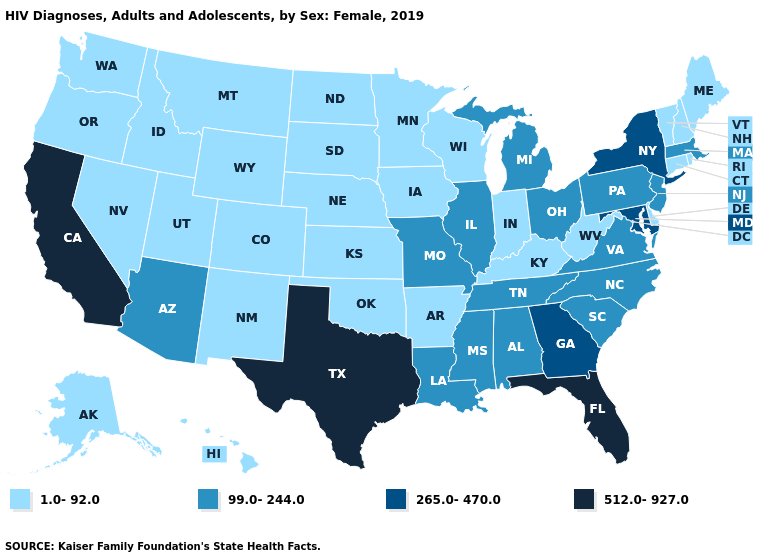Does New Mexico have a higher value than Kansas?
Quick response, please. No. Name the states that have a value in the range 1.0-92.0?
Write a very short answer. Alaska, Arkansas, Colorado, Connecticut, Delaware, Hawaii, Idaho, Indiana, Iowa, Kansas, Kentucky, Maine, Minnesota, Montana, Nebraska, Nevada, New Hampshire, New Mexico, North Dakota, Oklahoma, Oregon, Rhode Island, South Dakota, Utah, Vermont, Washington, West Virginia, Wisconsin, Wyoming. What is the value of Arkansas?
Write a very short answer. 1.0-92.0. What is the value of New Jersey?
Be succinct. 99.0-244.0. Among the states that border Indiana , which have the lowest value?
Concise answer only. Kentucky. Does Massachusetts have the lowest value in the USA?
Be succinct. No. Among the states that border Pennsylvania , does West Virginia have the lowest value?
Write a very short answer. Yes. Is the legend a continuous bar?
Quick response, please. No. What is the value of Connecticut?
Keep it brief. 1.0-92.0. Does Colorado have the lowest value in the USA?
Quick response, please. Yes. Name the states that have a value in the range 512.0-927.0?
Keep it brief. California, Florida, Texas. What is the lowest value in states that border New York?
Short answer required. 1.0-92.0. Which states have the highest value in the USA?
Write a very short answer. California, Florida, Texas. Name the states that have a value in the range 265.0-470.0?
Write a very short answer. Georgia, Maryland, New York. Among the states that border South Dakota , which have the highest value?
Give a very brief answer. Iowa, Minnesota, Montana, Nebraska, North Dakota, Wyoming. 